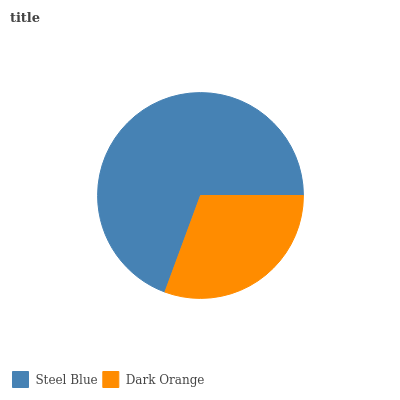Is Dark Orange the minimum?
Answer yes or no. Yes. Is Steel Blue the maximum?
Answer yes or no. Yes. Is Dark Orange the maximum?
Answer yes or no. No. Is Steel Blue greater than Dark Orange?
Answer yes or no. Yes. Is Dark Orange less than Steel Blue?
Answer yes or no. Yes. Is Dark Orange greater than Steel Blue?
Answer yes or no. No. Is Steel Blue less than Dark Orange?
Answer yes or no. No. Is Steel Blue the high median?
Answer yes or no. Yes. Is Dark Orange the low median?
Answer yes or no. Yes. Is Dark Orange the high median?
Answer yes or no. No. Is Steel Blue the low median?
Answer yes or no. No. 